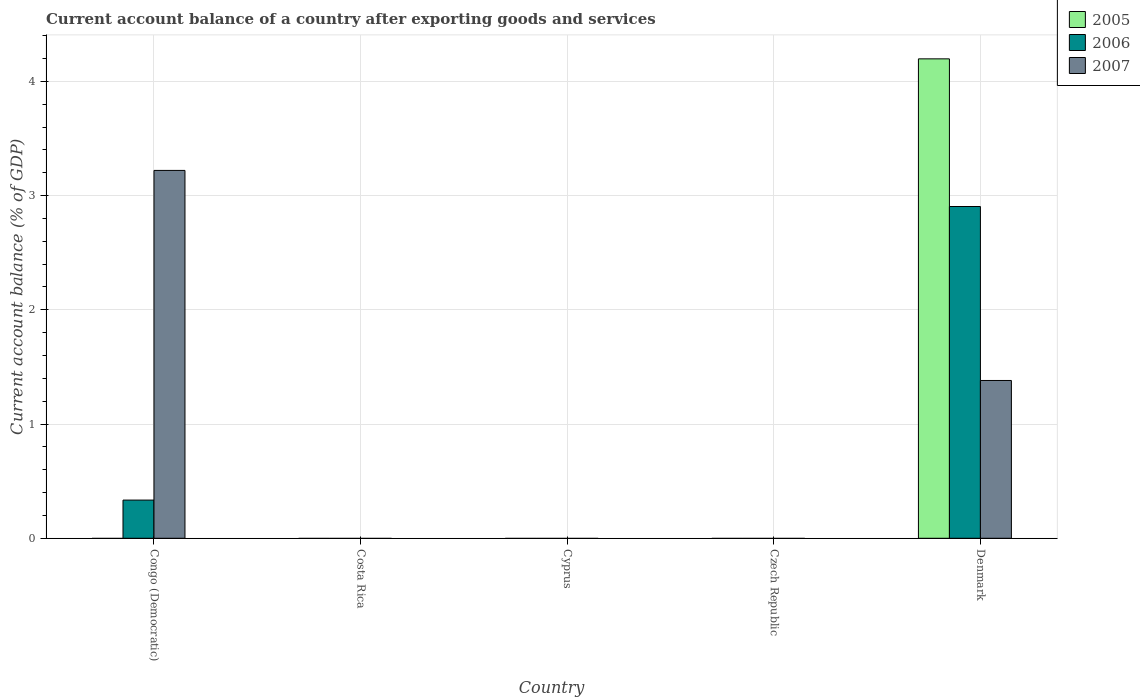How many different coloured bars are there?
Provide a succinct answer. 3. Are the number of bars per tick equal to the number of legend labels?
Give a very brief answer. No. How many bars are there on the 3rd tick from the right?
Give a very brief answer. 0. What is the label of the 4th group of bars from the left?
Provide a succinct answer. Czech Republic. In how many cases, is the number of bars for a given country not equal to the number of legend labels?
Your response must be concise. 4. What is the account balance in 2006 in Congo (Democratic)?
Make the answer very short. 0.33. Across all countries, what is the maximum account balance in 2007?
Your answer should be compact. 3.22. What is the total account balance in 2005 in the graph?
Your answer should be compact. 4.2. What is the average account balance in 2006 per country?
Your answer should be very brief. 0.65. What is the difference between the account balance of/in 2006 and account balance of/in 2005 in Denmark?
Offer a very short reply. -1.29. In how many countries, is the account balance in 2005 greater than 3.8 %?
Offer a terse response. 1. What is the difference between the highest and the lowest account balance in 2007?
Ensure brevity in your answer.  3.22. Is it the case that in every country, the sum of the account balance in 2005 and account balance in 2007 is greater than the account balance in 2006?
Offer a very short reply. No. What is the difference between two consecutive major ticks on the Y-axis?
Give a very brief answer. 1. Are the values on the major ticks of Y-axis written in scientific E-notation?
Make the answer very short. No. Does the graph contain grids?
Make the answer very short. Yes. How many legend labels are there?
Offer a terse response. 3. What is the title of the graph?
Your answer should be compact. Current account balance of a country after exporting goods and services. Does "1975" appear as one of the legend labels in the graph?
Ensure brevity in your answer.  No. What is the label or title of the Y-axis?
Offer a very short reply. Current account balance (% of GDP). What is the Current account balance (% of GDP) in 2006 in Congo (Democratic)?
Your answer should be very brief. 0.33. What is the Current account balance (% of GDP) in 2007 in Congo (Democratic)?
Your response must be concise. 3.22. What is the Current account balance (% of GDP) in 2005 in Cyprus?
Provide a succinct answer. 0. What is the Current account balance (% of GDP) of 2006 in Cyprus?
Your response must be concise. 0. What is the Current account balance (% of GDP) in 2005 in Czech Republic?
Offer a very short reply. 0. What is the Current account balance (% of GDP) in 2006 in Czech Republic?
Your answer should be compact. 0. What is the Current account balance (% of GDP) of 2007 in Czech Republic?
Offer a very short reply. 0. What is the Current account balance (% of GDP) in 2005 in Denmark?
Offer a very short reply. 4.2. What is the Current account balance (% of GDP) in 2006 in Denmark?
Ensure brevity in your answer.  2.9. What is the Current account balance (% of GDP) of 2007 in Denmark?
Offer a terse response. 1.38. Across all countries, what is the maximum Current account balance (% of GDP) of 2005?
Ensure brevity in your answer.  4.2. Across all countries, what is the maximum Current account balance (% of GDP) of 2006?
Ensure brevity in your answer.  2.9. Across all countries, what is the maximum Current account balance (% of GDP) in 2007?
Ensure brevity in your answer.  3.22. Across all countries, what is the minimum Current account balance (% of GDP) in 2005?
Your answer should be very brief. 0. Across all countries, what is the minimum Current account balance (% of GDP) in 2007?
Make the answer very short. 0. What is the total Current account balance (% of GDP) in 2005 in the graph?
Offer a terse response. 4.2. What is the total Current account balance (% of GDP) in 2006 in the graph?
Provide a succinct answer. 3.24. What is the total Current account balance (% of GDP) of 2007 in the graph?
Make the answer very short. 4.6. What is the difference between the Current account balance (% of GDP) in 2006 in Congo (Democratic) and that in Denmark?
Offer a terse response. -2.57. What is the difference between the Current account balance (% of GDP) of 2007 in Congo (Democratic) and that in Denmark?
Ensure brevity in your answer.  1.84. What is the difference between the Current account balance (% of GDP) in 2006 in Congo (Democratic) and the Current account balance (% of GDP) in 2007 in Denmark?
Offer a very short reply. -1.05. What is the average Current account balance (% of GDP) in 2005 per country?
Provide a succinct answer. 0.84. What is the average Current account balance (% of GDP) in 2006 per country?
Offer a very short reply. 0.65. What is the average Current account balance (% of GDP) in 2007 per country?
Your answer should be very brief. 0.92. What is the difference between the Current account balance (% of GDP) in 2006 and Current account balance (% of GDP) in 2007 in Congo (Democratic)?
Provide a short and direct response. -2.89. What is the difference between the Current account balance (% of GDP) in 2005 and Current account balance (% of GDP) in 2006 in Denmark?
Ensure brevity in your answer.  1.29. What is the difference between the Current account balance (% of GDP) of 2005 and Current account balance (% of GDP) of 2007 in Denmark?
Provide a short and direct response. 2.82. What is the difference between the Current account balance (% of GDP) in 2006 and Current account balance (% of GDP) in 2007 in Denmark?
Ensure brevity in your answer.  1.52. What is the ratio of the Current account balance (% of GDP) in 2006 in Congo (Democratic) to that in Denmark?
Ensure brevity in your answer.  0.12. What is the ratio of the Current account balance (% of GDP) in 2007 in Congo (Democratic) to that in Denmark?
Your answer should be very brief. 2.33. What is the difference between the highest and the lowest Current account balance (% of GDP) in 2005?
Keep it short and to the point. 4.2. What is the difference between the highest and the lowest Current account balance (% of GDP) of 2006?
Make the answer very short. 2.9. What is the difference between the highest and the lowest Current account balance (% of GDP) in 2007?
Provide a succinct answer. 3.22. 